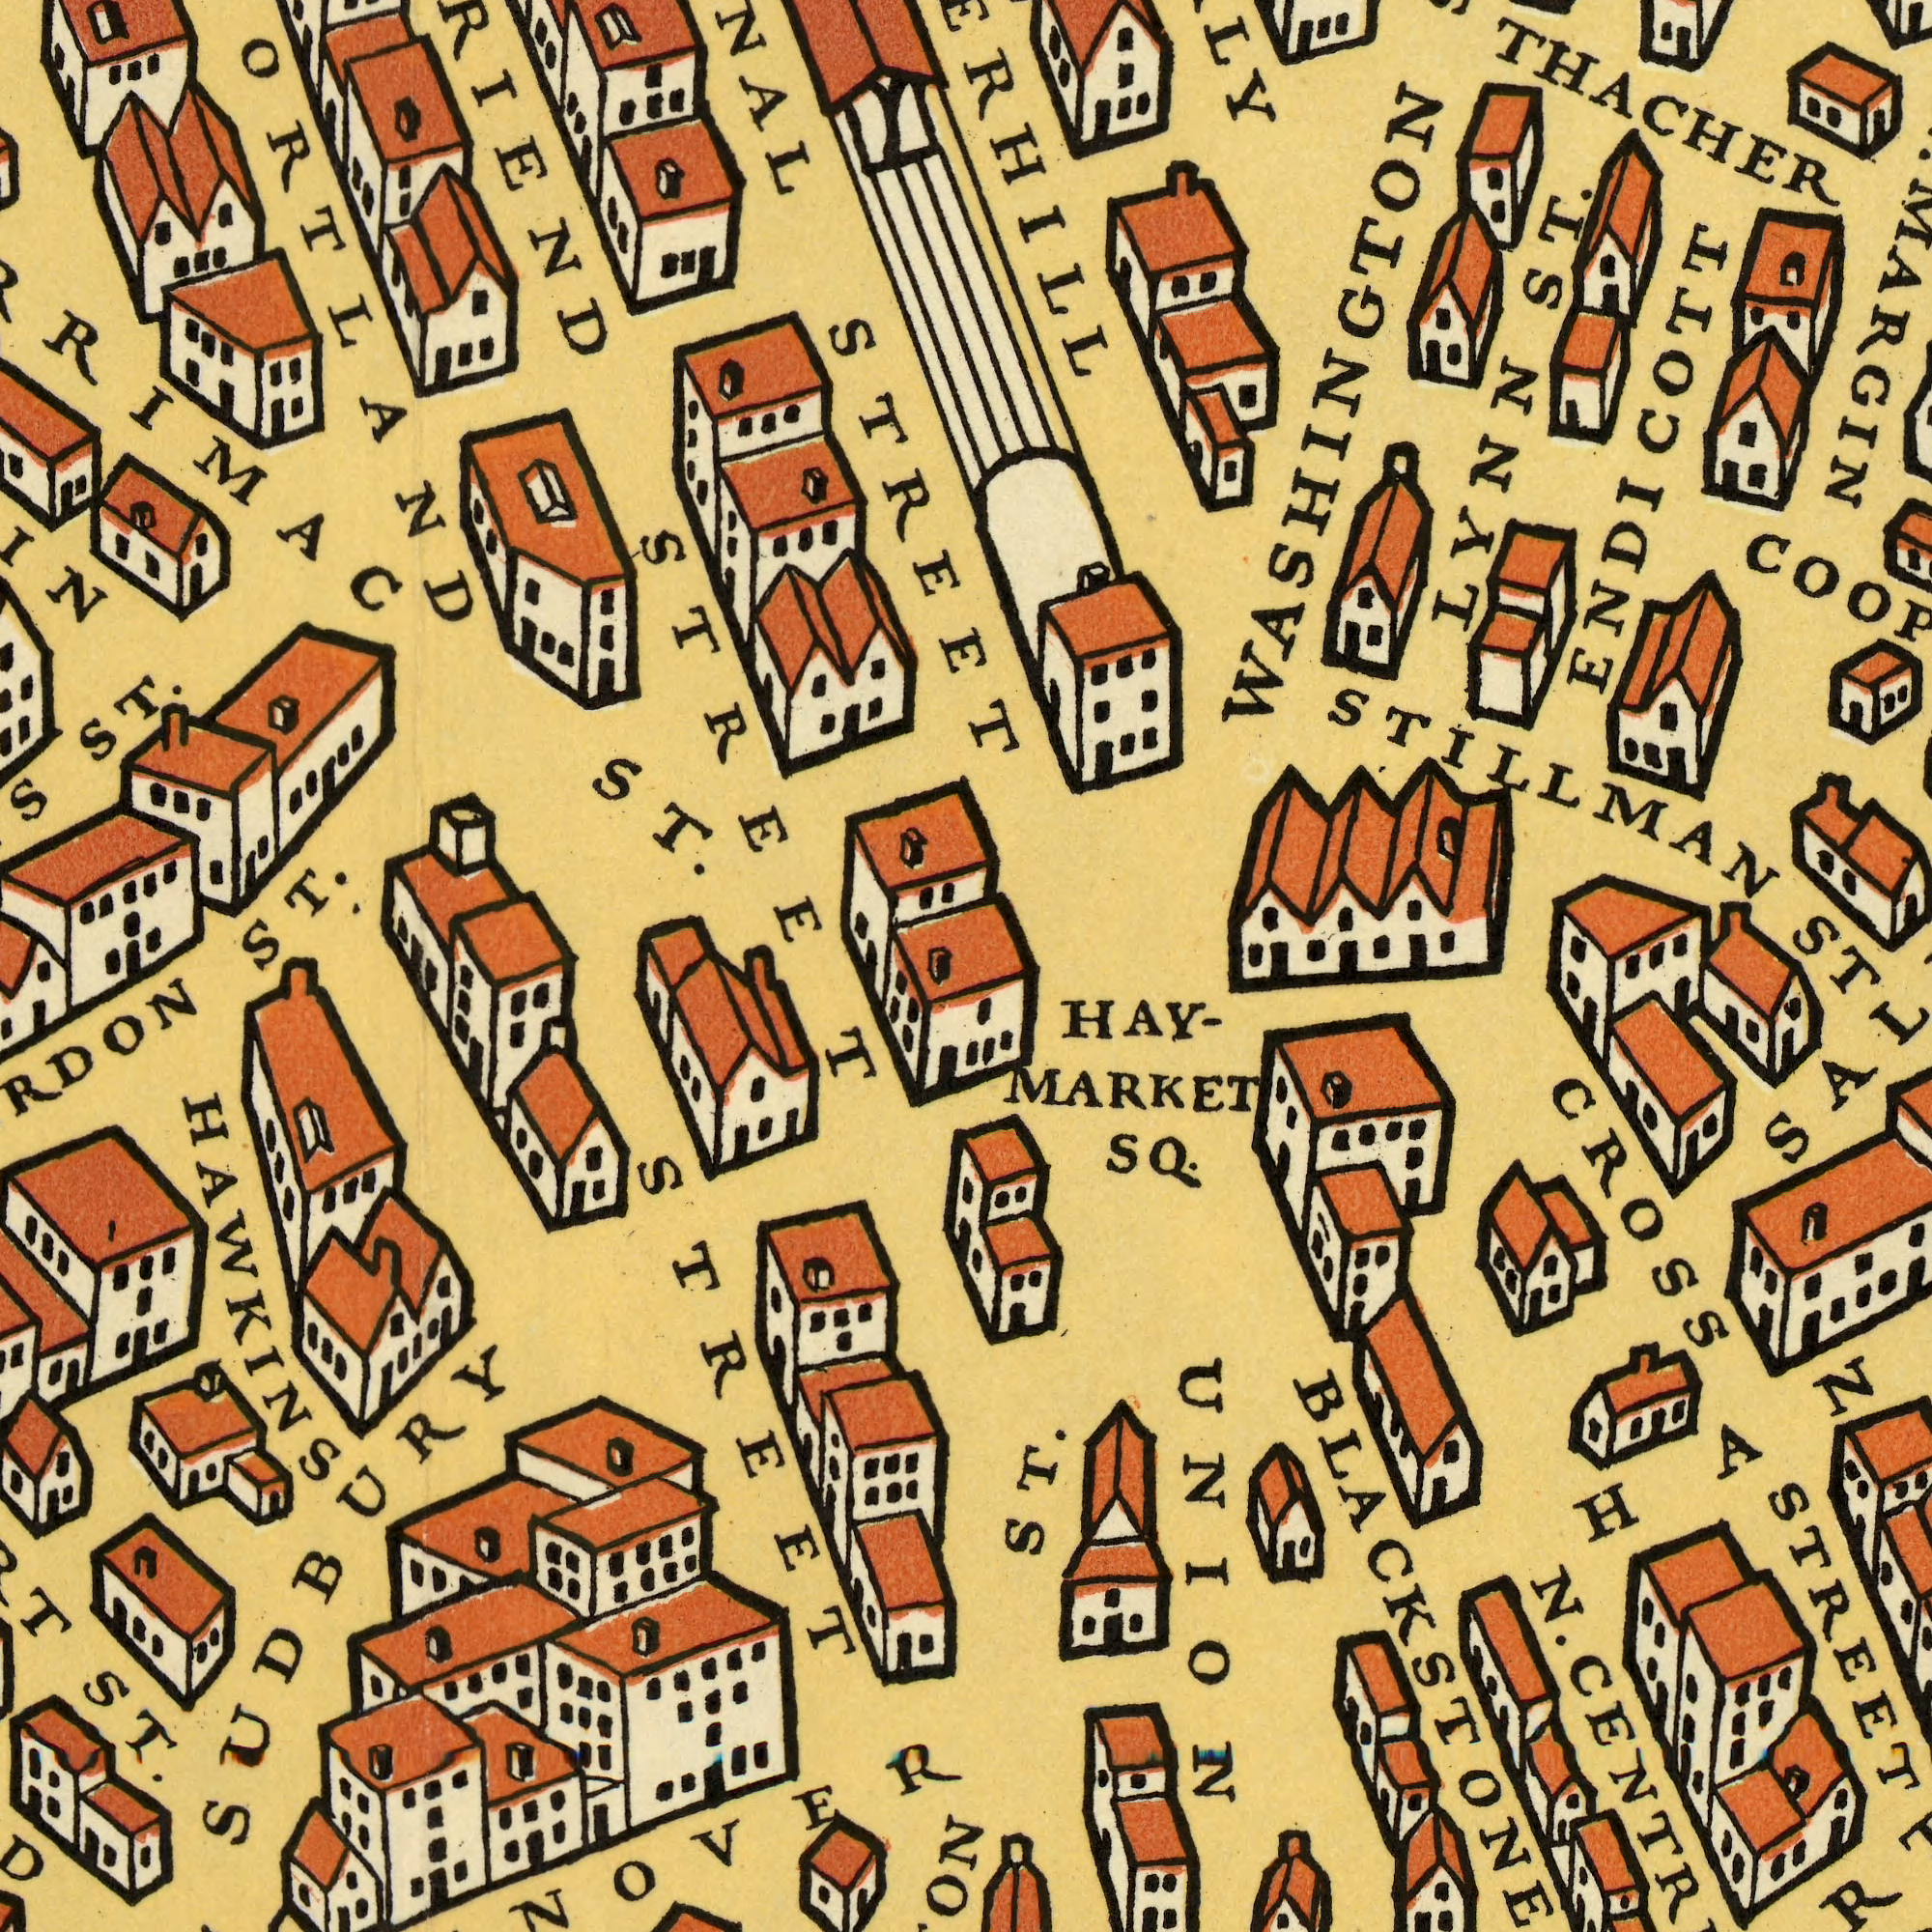What text appears in the top-right area of the image? THACHER LYNN ST. STILLMAN ENDICOTT WASHINGTON What text is visible in the upper-left corner? STREET ST. ST. ST. STREET ###ORTLAND What text is shown in the bottom-left quadrant? STREET ST. HAWKINS SUDBURY What text is visible in the lower-right corner? ST ST. N. HAY- MARKET SQ. CROSS STREET UNION 